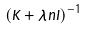<formula> <loc_0><loc_0><loc_500><loc_500>( \hat { K } + \lambda n I ) ^ { - 1 }</formula> 